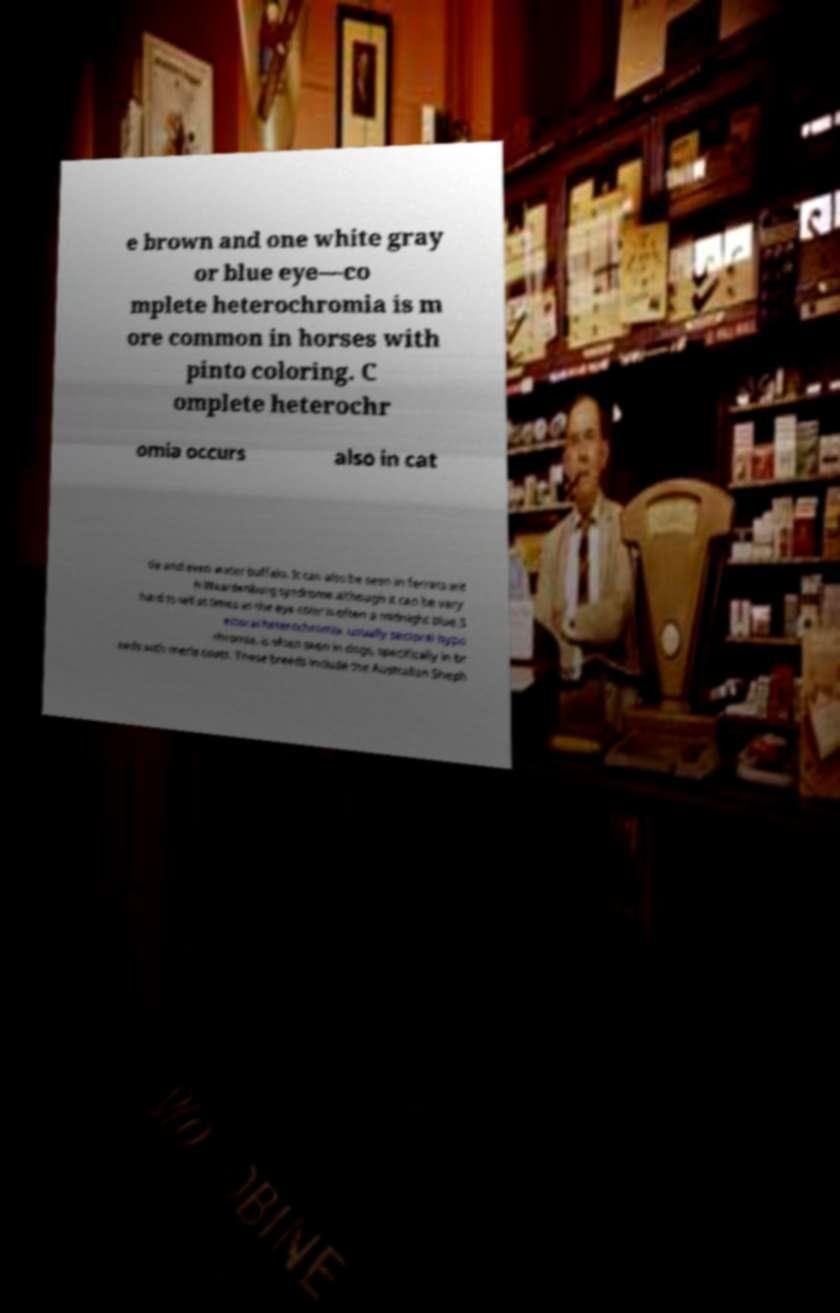Please identify and transcribe the text found in this image. e brown and one white gray or blue eye—co mplete heterochromia is m ore common in horses with pinto coloring. C omplete heterochr omia occurs also in cat tle and even water buffalo. It can also be seen in ferrets wit h Waardenburg syndrome although it can be very hard to tell at times as the eye color is often a midnight blue.S ectoral heterochromia, usually sectoral hypo chromia, is often seen in dogs, specifically in br eeds with merle coats. These breeds include the Australian Sheph 